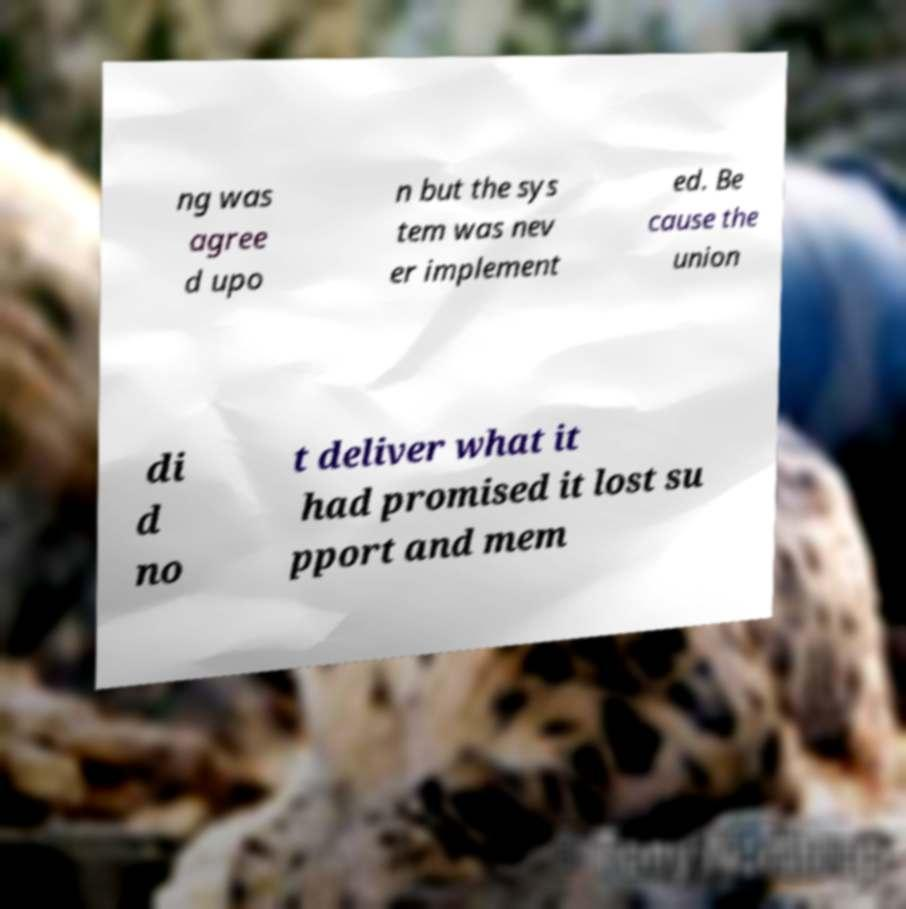I need the written content from this picture converted into text. Can you do that? ng was agree d upo n but the sys tem was nev er implement ed. Be cause the union di d no t deliver what it had promised it lost su pport and mem 